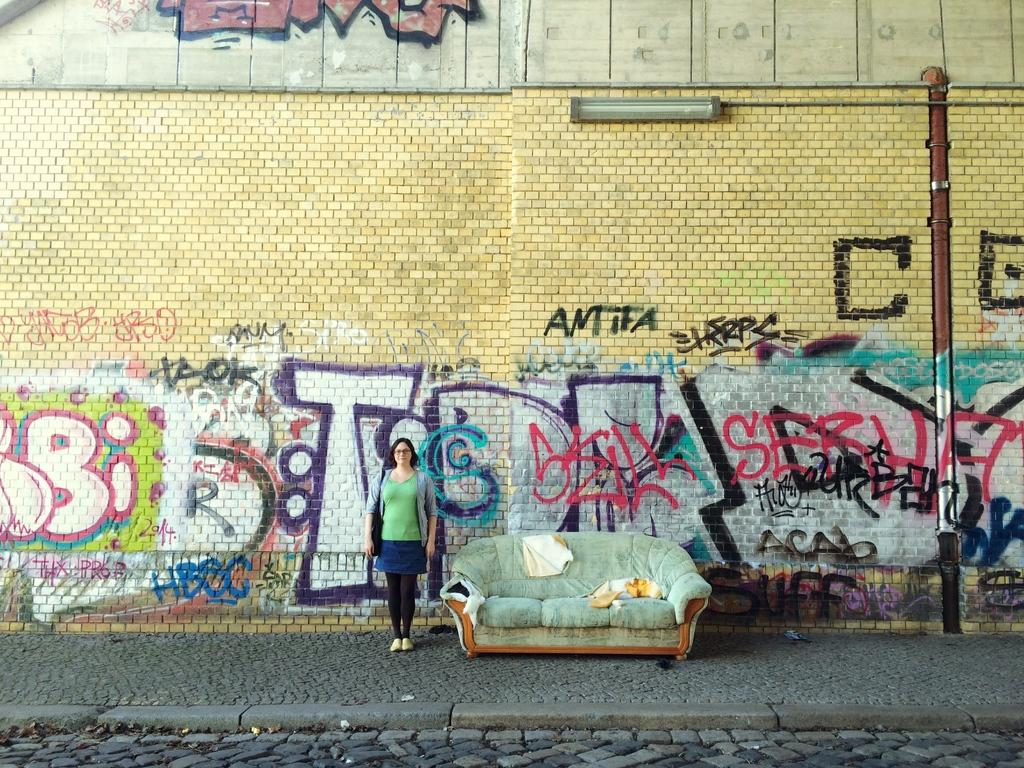Who is the main subject in the image? There is a girl in the image. Where is the girl standing? The girl is standing on a pedestrian walking area. What can be seen on the wall in the image? There is a big wall with a spray art design in the image. What piece of furniture is beside the girl? There is a couch beside the girl. What type of sand can be seen in the image? There is no sand present in the image. What event is taking place in the image? The image does not depict a specific event; it shows a girl standing on a pedestrian walking area with a wall and couch nearby. 